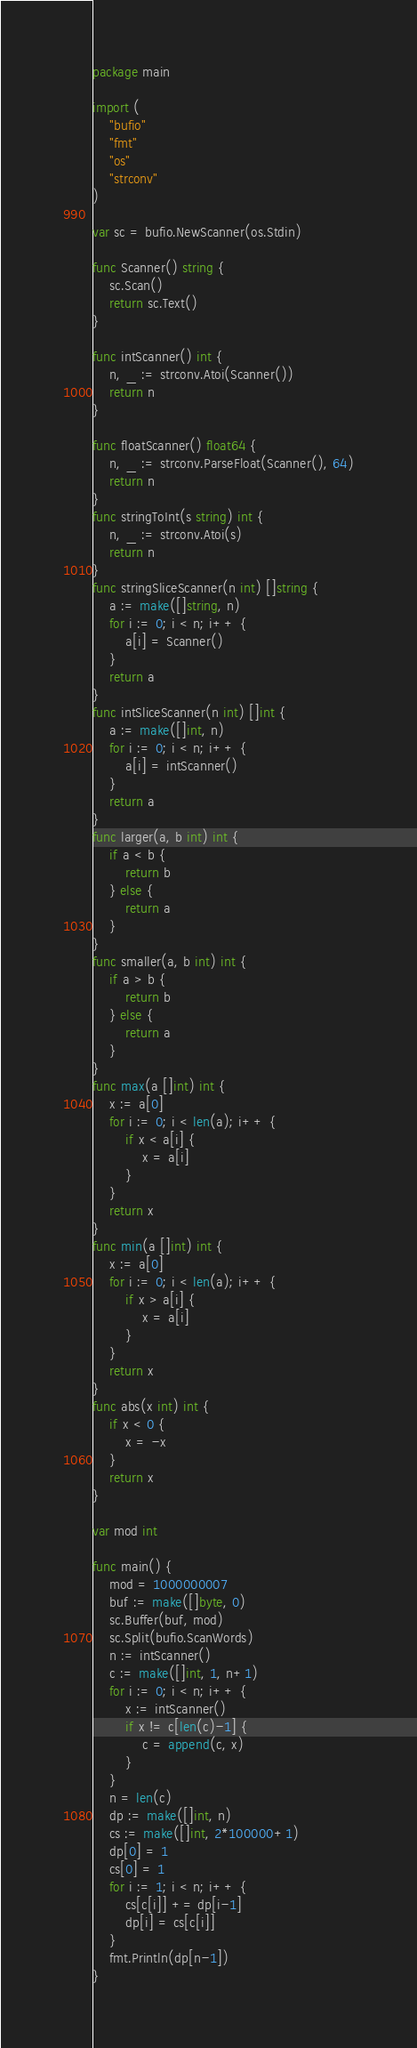Convert code to text. <code><loc_0><loc_0><loc_500><loc_500><_Go_>package main

import (
	"bufio"
	"fmt"
	"os"
	"strconv"
)

var sc = bufio.NewScanner(os.Stdin)

func Scanner() string {
	sc.Scan()
	return sc.Text()
}

func intScanner() int {
	n, _ := strconv.Atoi(Scanner())
	return n
}

func floatScanner() float64 {
	n, _ := strconv.ParseFloat(Scanner(), 64)
	return n
}
func stringToInt(s string) int {
	n, _ := strconv.Atoi(s)
	return n
}
func stringSliceScanner(n int) []string {
	a := make([]string, n)
	for i := 0; i < n; i++ {
		a[i] = Scanner()
	}
	return a
}
func intSliceScanner(n int) []int {
	a := make([]int, n)
	for i := 0; i < n; i++ {
		a[i] = intScanner()
	}
	return a
}
func larger(a, b int) int {
	if a < b {
		return b
	} else {
		return a
	}
}
func smaller(a, b int) int {
	if a > b {
		return b
	} else {
		return a
	}
}
func max(a []int) int {
	x := a[0]
	for i := 0; i < len(a); i++ {
		if x < a[i] {
			x = a[i]
		}
	}
	return x
}
func min(a []int) int {
	x := a[0]
	for i := 0; i < len(a); i++ {
		if x > a[i] {
			x = a[i]
		}
	}
	return x
}
func abs(x int) int {
	if x < 0 {
		x = -x
	}
	return x
}

var mod int

func main() {
	mod = 1000000007
	buf := make([]byte, 0)
	sc.Buffer(buf, mod)
	sc.Split(bufio.ScanWords)
	n := intScanner()
	c := make([]int, 1, n+1)
	for i := 0; i < n; i++ {
		x := intScanner()
		if x != c[len(c)-1] {
			c = append(c, x)
		}
	}
	n = len(c)
	dp := make([]int, n)
	cs := make([]int, 2*100000+1)
	dp[0] = 1
	cs[0] = 1
	for i := 1; i < n; i++ {
		cs[c[i]] += dp[i-1]
		dp[i] = cs[c[i]]
	}
	fmt.Println(dp[n-1])
}
</code> 